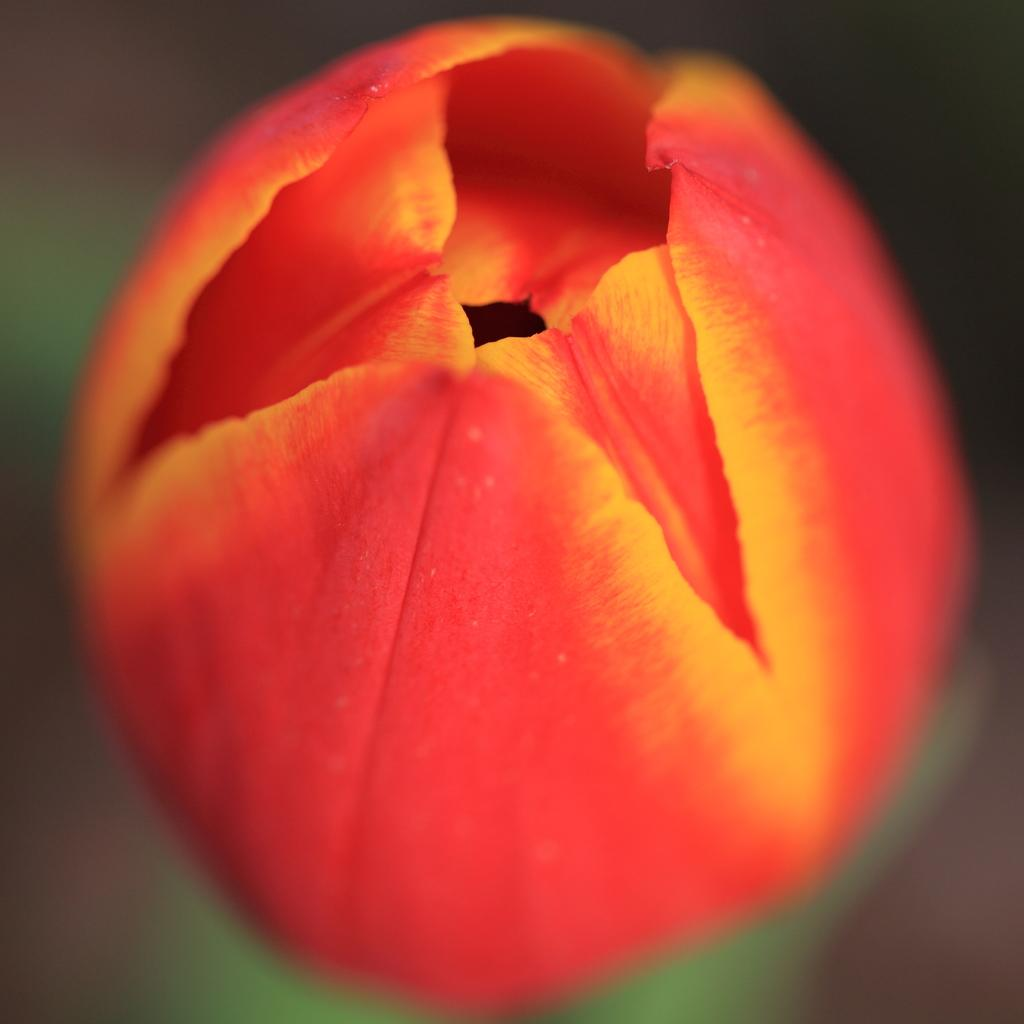What colors are present in the object in the image? The object in the image has red and yellow colors. Can you describe the surroundings of the object in the image? The area around the object is blurry. What type of humor can be seen in the image? There is no humor present in the image; it features a red and yellow object with a blurry background. Can you describe the nest in the image? There is no nest present in the image; it only contains a red and yellow object with a blurry background. 